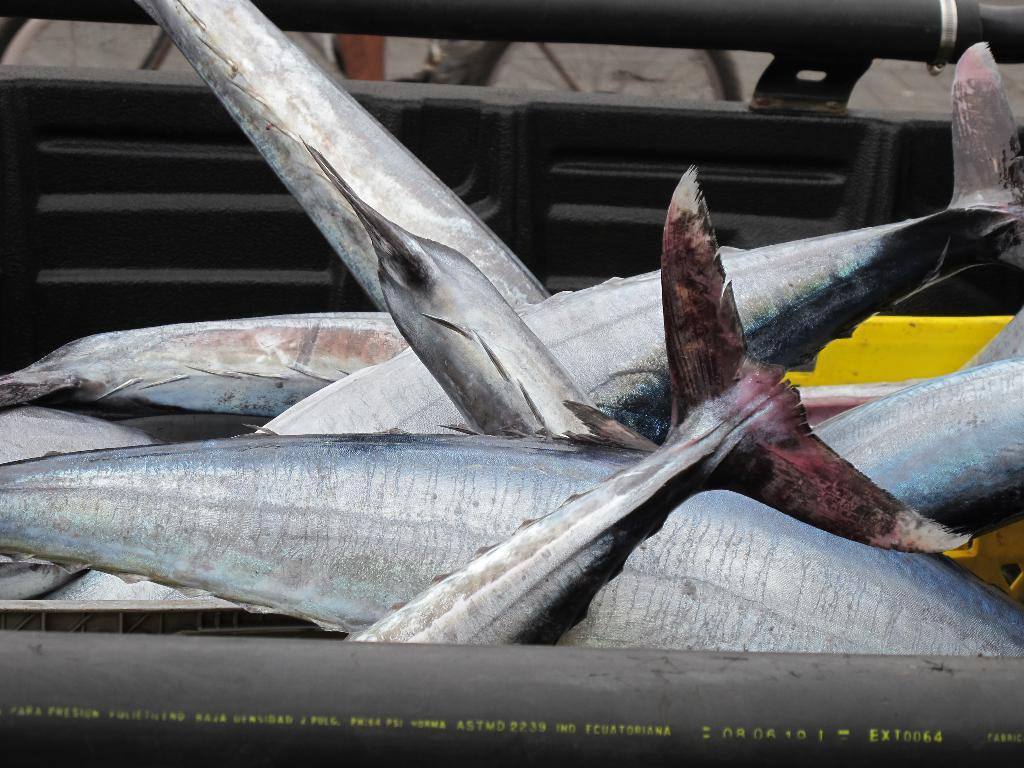What type of animals can be seen in the image? There are fishes in the image. What is the color of the tub containing the fishes? The tub containing the fishes is black in color. Are there any bells hanging from the fishes in the image? No, there are no bells present in the image. 